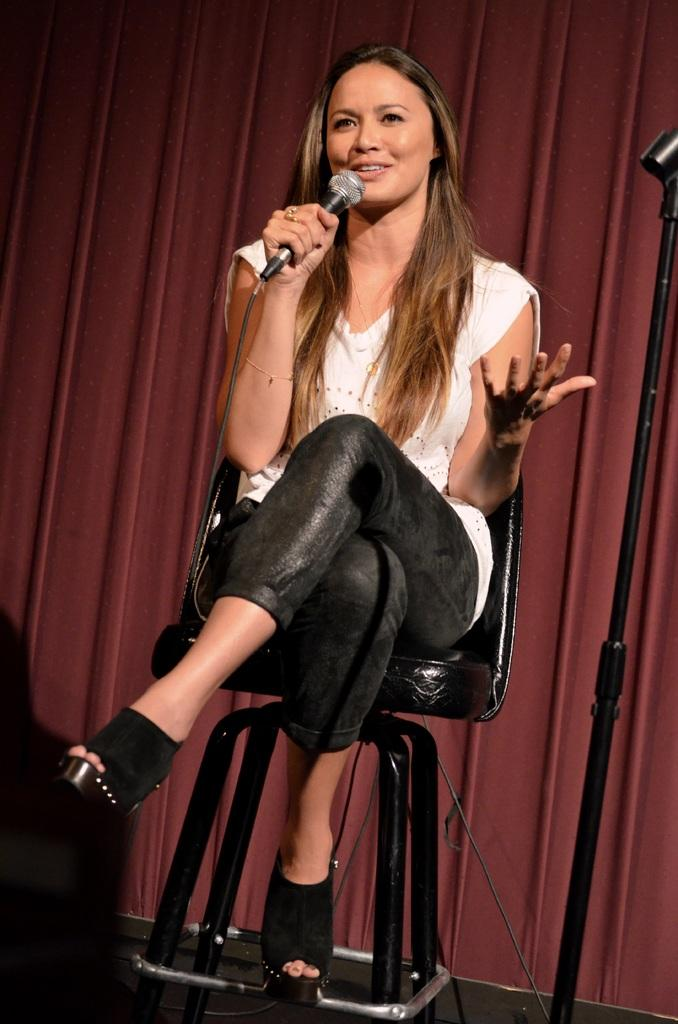Who is the main subject in the image? There is a lady sitting in the center of the image. What is the lady holding in the image? The lady is holding a mic. What can be seen in the background of the image? There is a curtain in the background of the image. What is located on the right side of the image? There is a stand on the right side of the image. What type of oven is visible in the image? There is no oven present in the image. How does the lady's daughter feel about her performance in the image? There is no mention of a daughter in the image, so it is impossible to determine her feelings. 